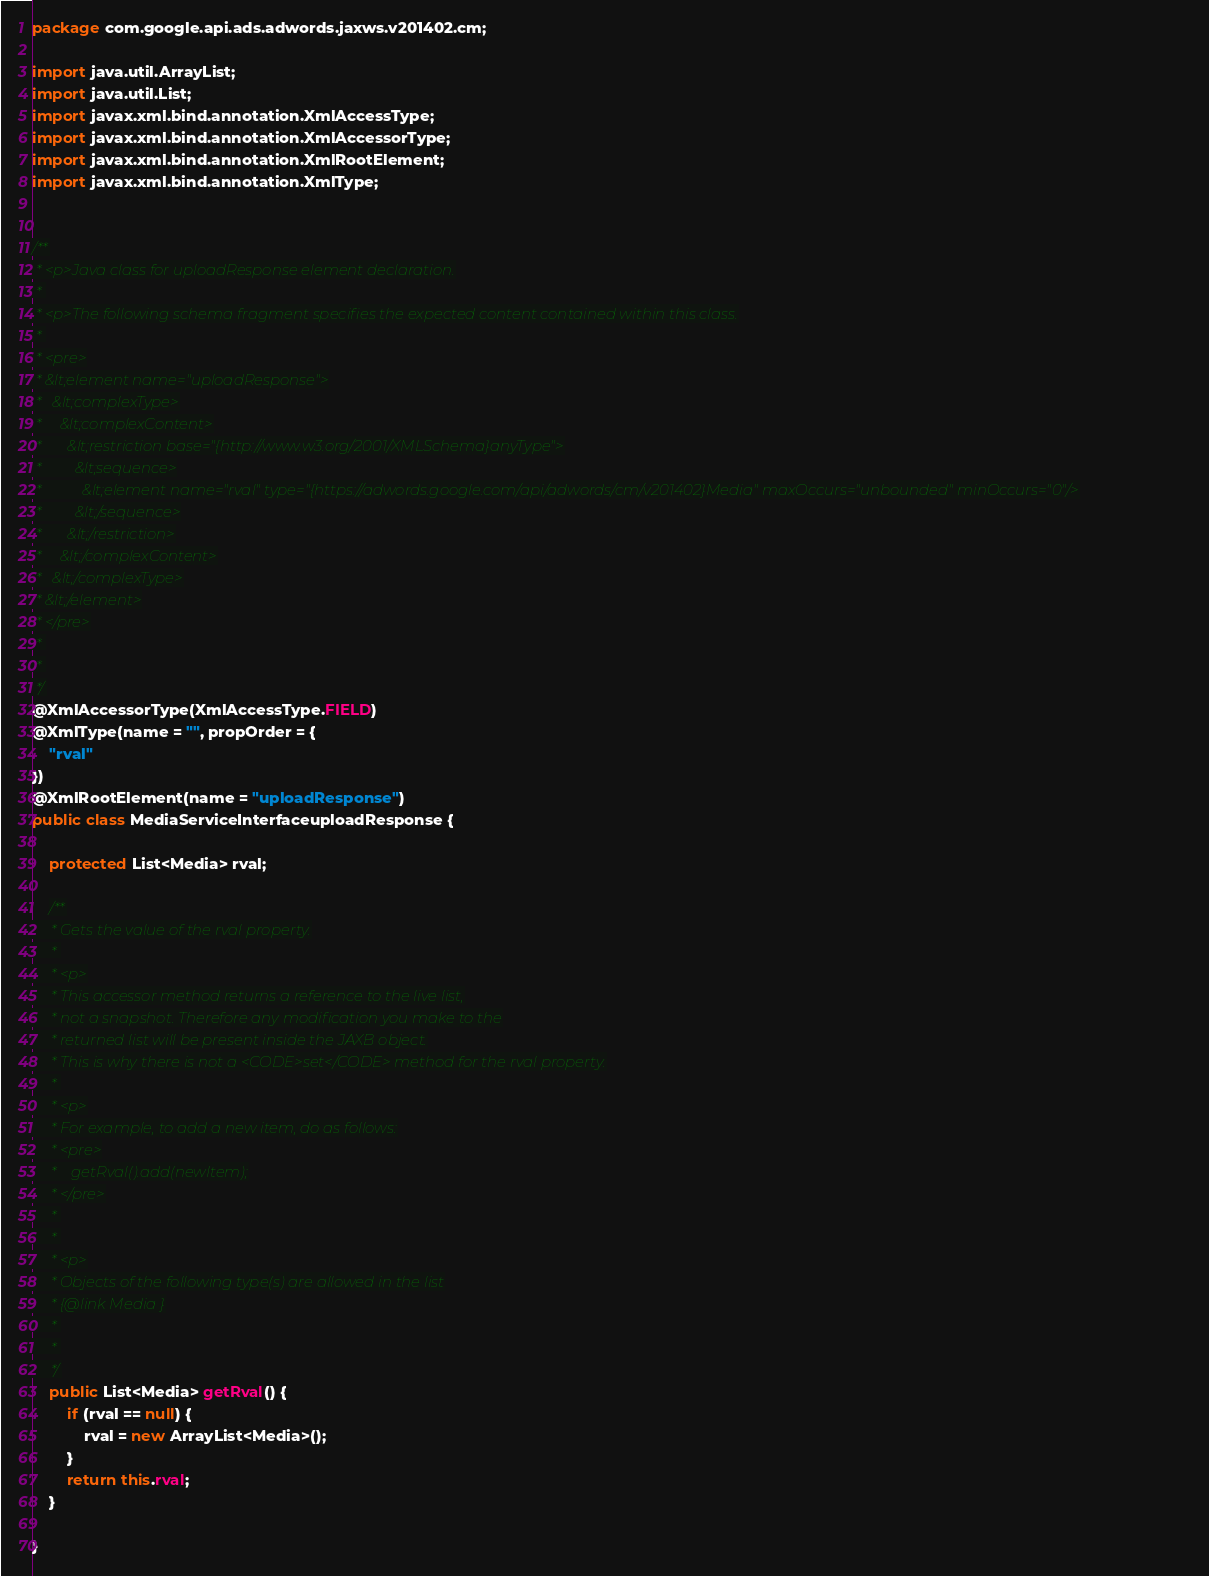Convert code to text. <code><loc_0><loc_0><loc_500><loc_500><_Java_>
package com.google.api.ads.adwords.jaxws.v201402.cm;

import java.util.ArrayList;
import java.util.List;
import javax.xml.bind.annotation.XmlAccessType;
import javax.xml.bind.annotation.XmlAccessorType;
import javax.xml.bind.annotation.XmlRootElement;
import javax.xml.bind.annotation.XmlType;


/**
 * <p>Java class for uploadResponse element declaration.
 * 
 * <p>The following schema fragment specifies the expected content contained within this class.
 * 
 * <pre>
 * &lt;element name="uploadResponse">
 *   &lt;complexType>
 *     &lt;complexContent>
 *       &lt;restriction base="{http://www.w3.org/2001/XMLSchema}anyType">
 *         &lt;sequence>
 *           &lt;element name="rval" type="{https://adwords.google.com/api/adwords/cm/v201402}Media" maxOccurs="unbounded" minOccurs="0"/>
 *         &lt;/sequence>
 *       &lt;/restriction>
 *     &lt;/complexContent>
 *   &lt;/complexType>
 * &lt;/element>
 * </pre>
 * 
 * 
 */
@XmlAccessorType(XmlAccessType.FIELD)
@XmlType(name = "", propOrder = {
    "rval"
})
@XmlRootElement(name = "uploadResponse")
public class MediaServiceInterfaceuploadResponse {

    protected List<Media> rval;

    /**
     * Gets the value of the rval property.
     * 
     * <p>
     * This accessor method returns a reference to the live list,
     * not a snapshot. Therefore any modification you make to the
     * returned list will be present inside the JAXB object.
     * This is why there is not a <CODE>set</CODE> method for the rval property.
     * 
     * <p>
     * For example, to add a new item, do as follows:
     * <pre>
     *    getRval().add(newItem);
     * </pre>
     * 
     * 
     * <p>
     * Objects of the following type(s) are allowed in the list
     * {@link Media }
     * 
     * 
     */
    public List<Media> getRval() {
        if (rval == null) {
            rval = new ArrayList<Media>();
        }
        return this.rval;
    }

}
</code> 